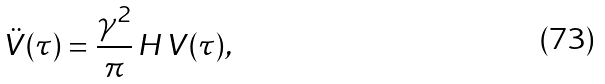<formula> <loc_0><loc_0><loc_500><loc_500>\ddot { V } ( \tau ) = \frac { \gamma ^ { 2 } } { \pi } \, H \, V ( \tau ) ,</formula> 